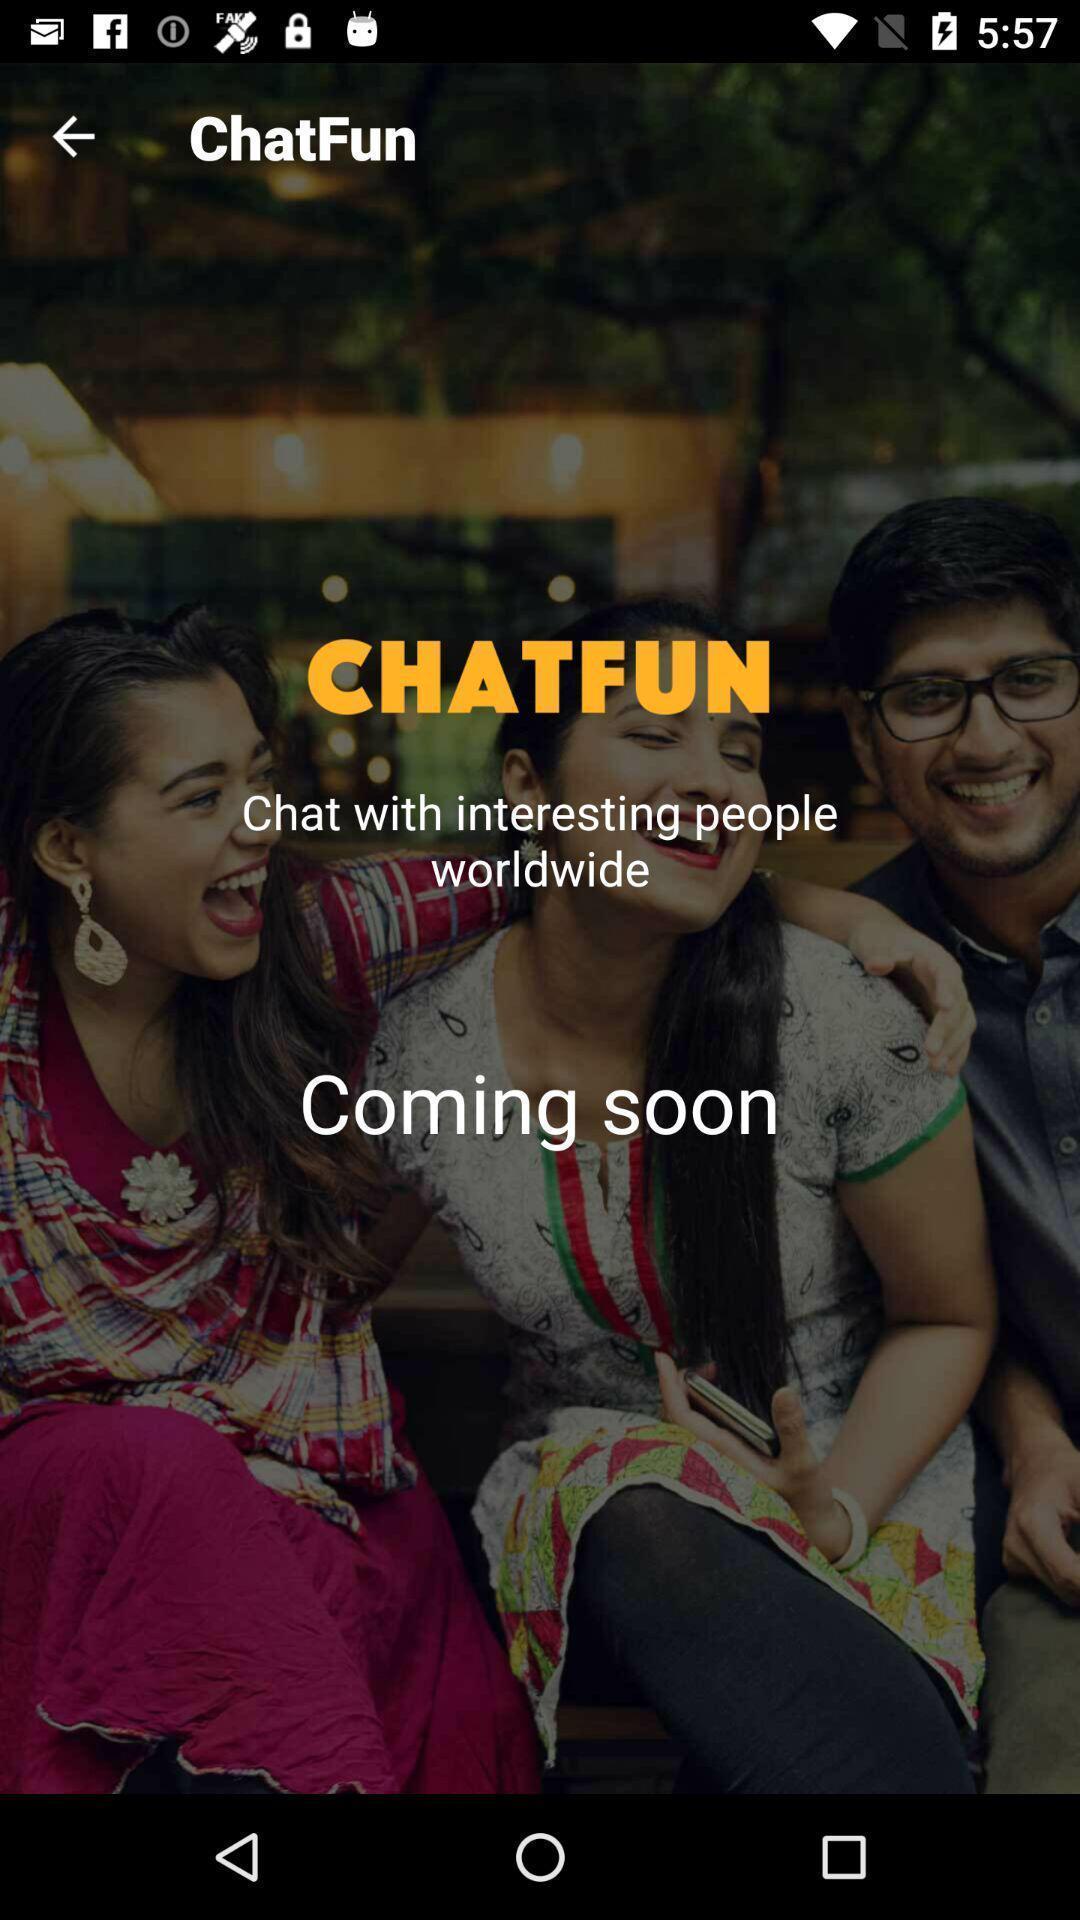Tell me what you see in this picture. Welcome page of a chatting app. 